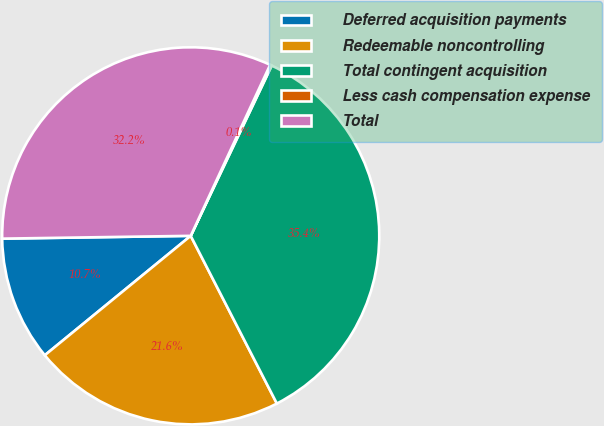Convert chart. <chart><loc_0><loc_0><loc_500><loc_500><pie_chart><fcel>Deferred acquisition payments<fcel>Redeemable noncontrolling<fcel>Total contingent acquisition<fcel>Less cash compensation expense<fcel>Total<nl><fcel>10.68%<fcel>21.64%<fcel>35.38%<fcel>0.15%<fcel>32.16%<nl></chart> 